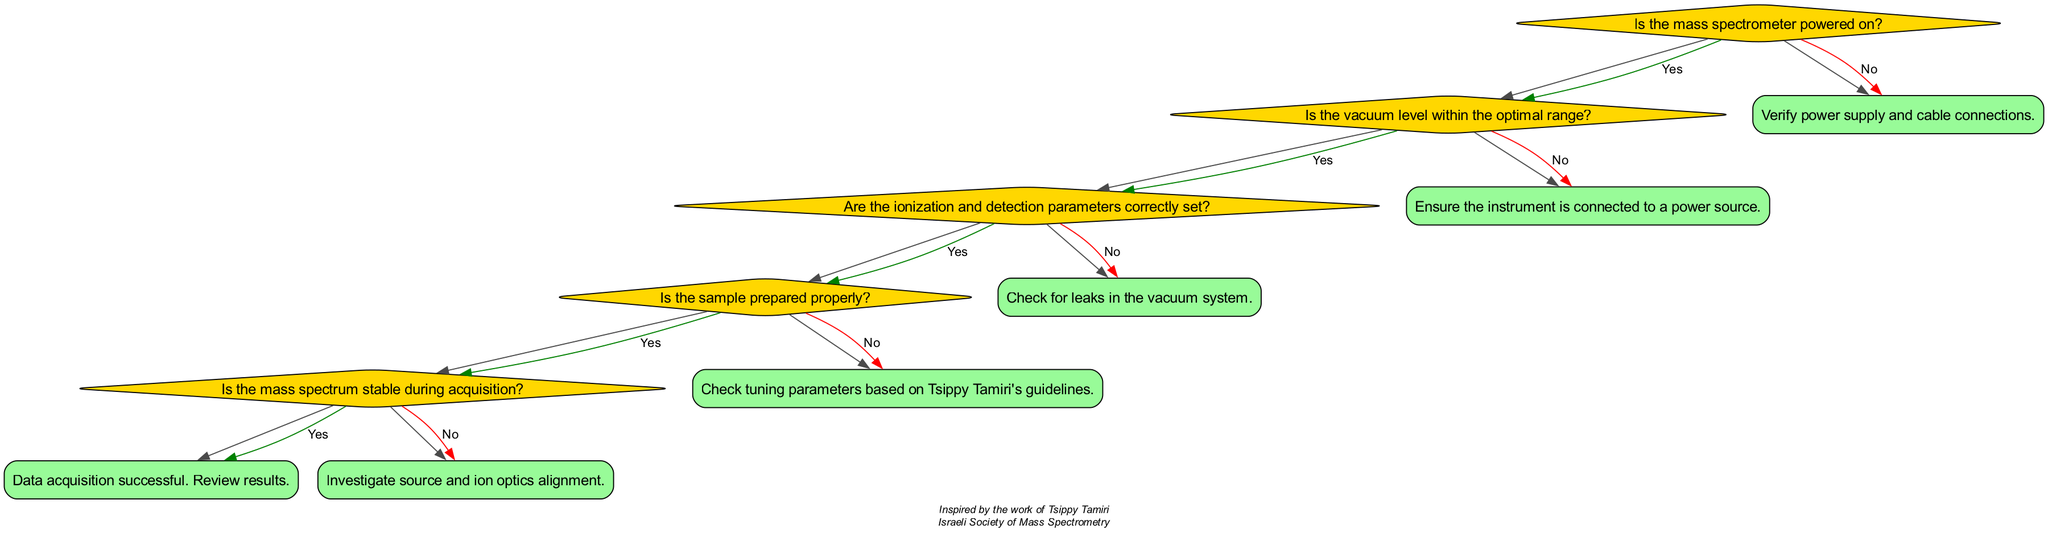Is the first question in the diagram focused on power? The first node presents the question "Is the mass spectrometer powered on?" which directly relates to the power status of the device. This indicates it is the first concern when troubleshooting.
Answer: Yes How many main questions are in the decision tree? The decision tree has a total of five main questions that direct the troubleshooting process. Each question leads to a further decision or solution based on the answers given.
Answer: Five What action is suggested if the vacuum level is not optimal? The flow for when the vacuum level is not within the optimal range directs to a solution: "Check for leaks in the vacuum system." This action addresses potential vacuum issues directly.
Answer: Check for leaks in the vacuum system What is the final solution if all conditions are met successfully? If the mass spectrometer is powered on, vacuum is optimal, parameters are set correctly, sample is prepared properly, and the spectrum is stable, then the solution is "Data acquisition successful. Review results." This indicates a successful troubleshooting pathway.
Answer: Data acquisition successful. Review results What is the solution if the ionization and detection parameters are incorrectly set? If the parameters are incorrectly set, the decision tree indicates the solution "Check tuning parameters based on Tsippy Tamiri's guidelines." This provides a specific reference for correcting the setup.
Answer: Check tuning parameters based on Tsippy Tamiri's guidelines What does the diagram suggest to do if the instrument is not powered on? If the mass spectrometer is not powered on, the solution indicates "Verify power supply and cable connections." This suggests checking both the power supply and the connections to ensure proper operation.
Answer: Verify power supply and cable connections 